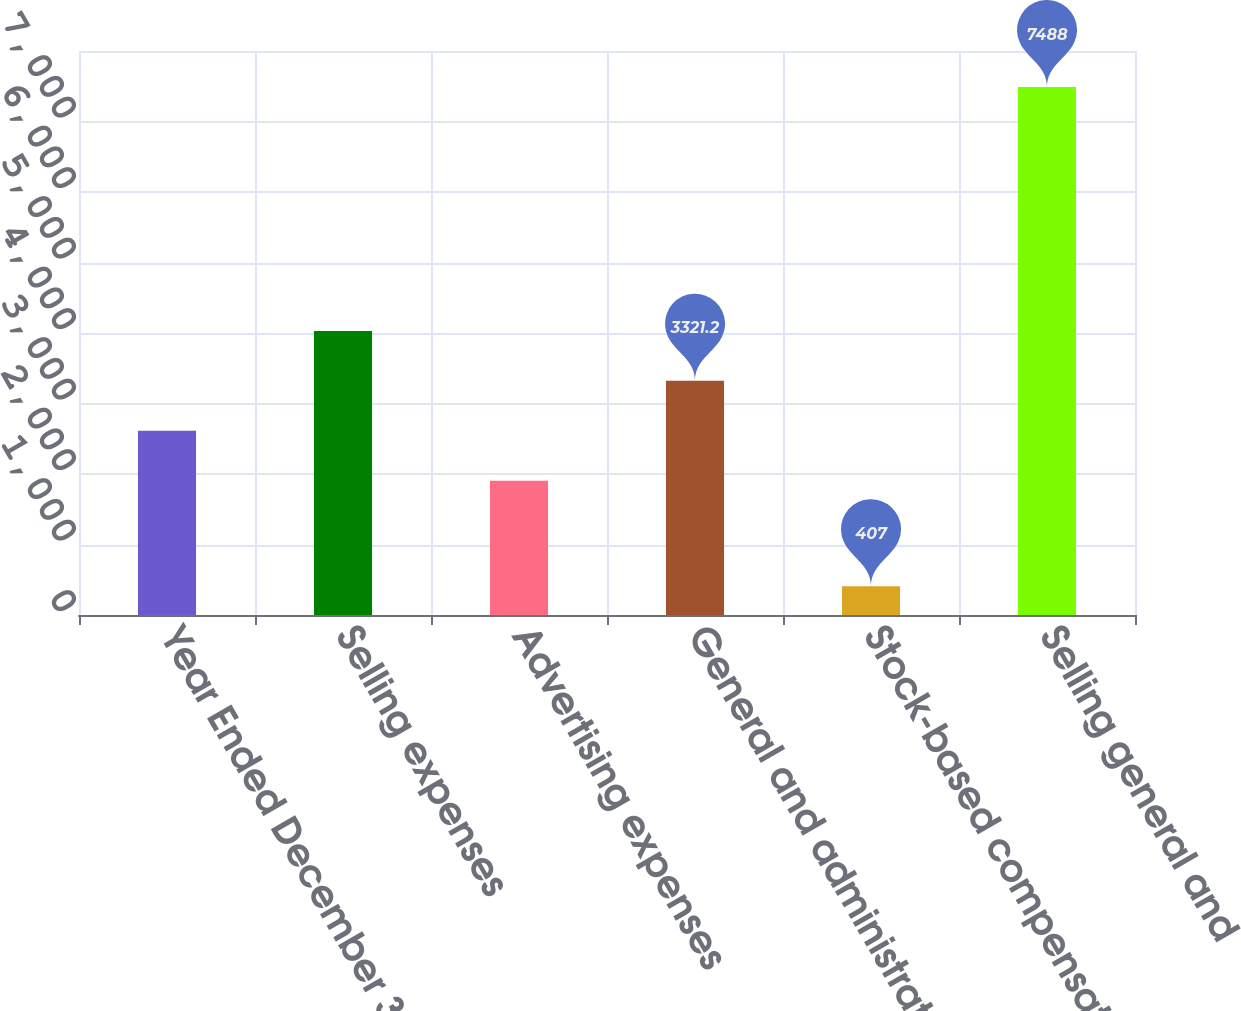Convert chart. <chart><loc_0><loc_0><loc_500><loc_500><bar_chart><fcel>Year Ended December 31<fcel>Selling expenses<fcel>Advertising expenses<fcel>General and administrative<fcel>Stock-based compensation<fcel>Selling general and<nl><fcel>2613.1<fcel>4029.3<fcel>1905<fcel>3321.2<fcel>407<fcel>7488<nl></chart> 